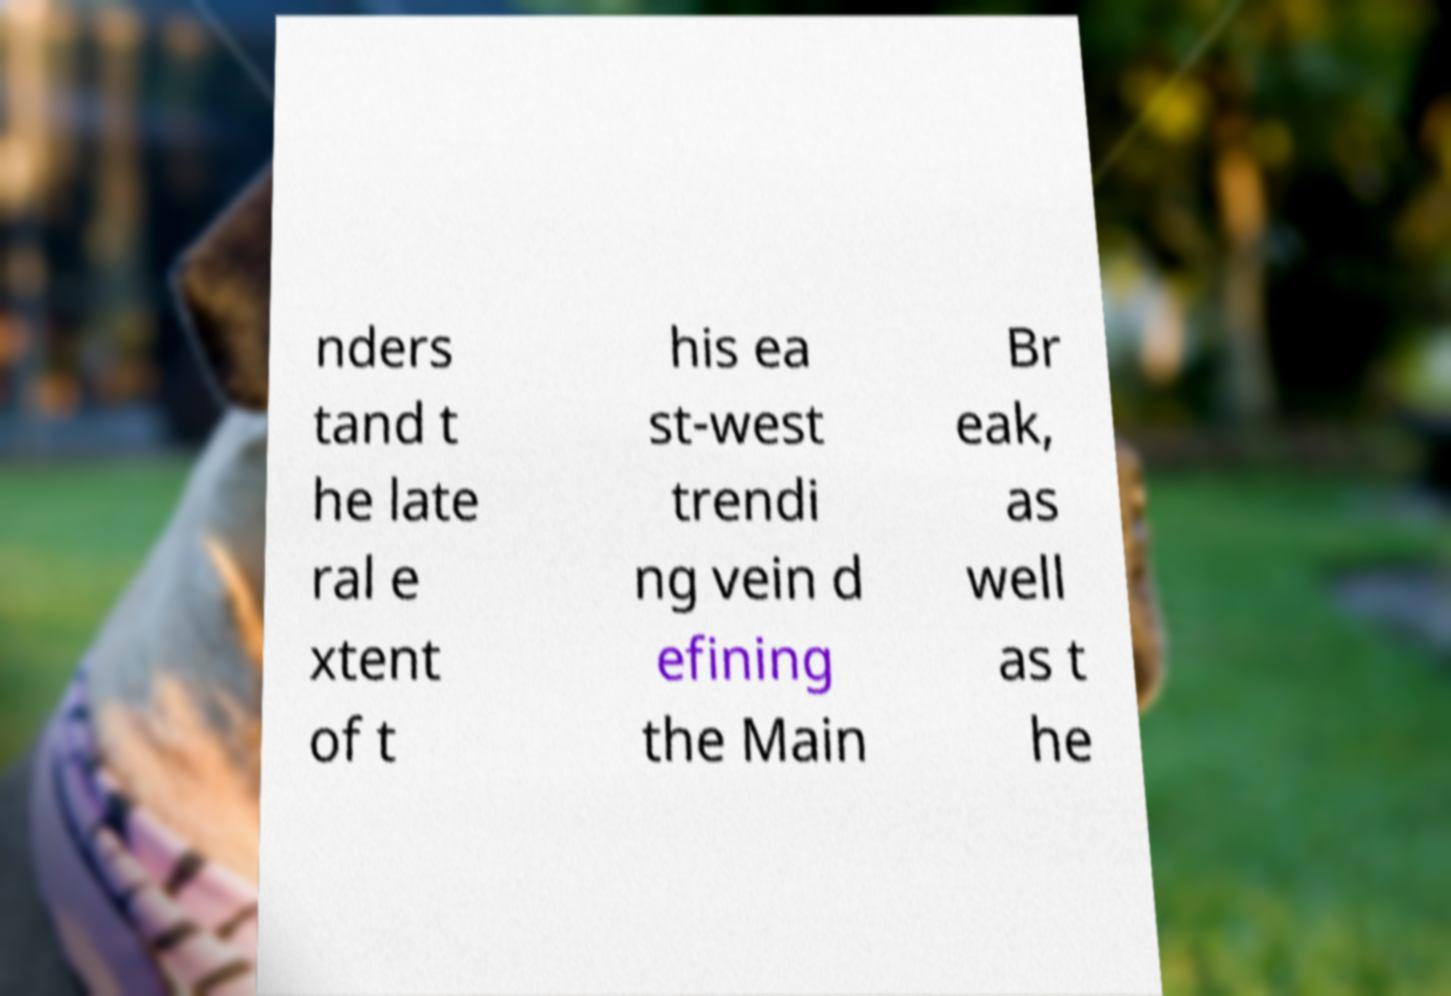Please identify and transcribe the text found in this image. nders tand t he late ral e xtent of t his ea st-west trendi ng vein d efining the Main Br eak, as well as t he 